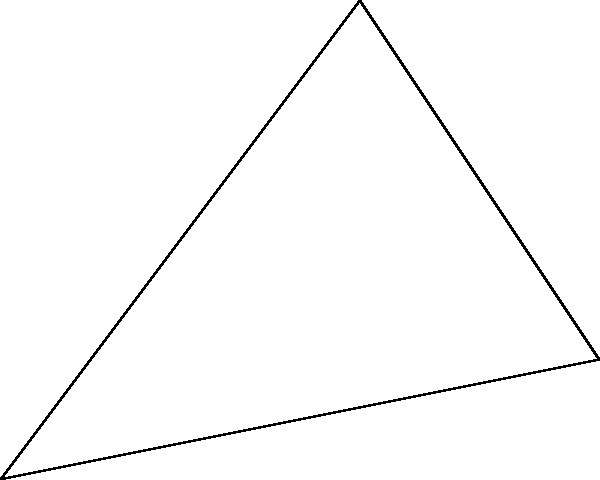In a plant's stem growth pattern, two branches emerge from the main stem at point O. Branch OA makes an angle $\alpha$ with the vertical axis, while branch OB makes an angle $\beta$ with the vertical axis. Given that OA = 5 cm, OB = $\sqrt{26}$ cm, and the horizontal distance between A and B is 2 cm, calculate the branching angle between OA and OB. To find the branching angle between OA and OB, we can follow these steps:

1) First, let's identify the triangle formed by points O, A, and B. We need to find the angle at O in this triangle.

2) We can use the cosine law to find this angle. The cosine law states:
   $c^2 = a^2 + b^2 - 2ab \cos(C)$
   where C is the angle opposite to side c.

3) In our case:
   $OA = 5$ cm
   $OB = \sqrt{26}$ cm
   $AB = 2$ cm (horizontal distance between A and B)

4) Let's call the angle we're looking for $\theta$. Applying the cosine law:
   $AB^2 = OA^2 + OB^2 - 2(OA)(OB)\cos(\theta)$

5) Substituting the known values:
   $2^2 = 5^2 + (\sqrt{26})^2 - 2(5)(\sqrt{26})\cos(\theta)$

6) Simplify:
   $4 = 25 + 26 - 10\sqrt{26}\cos(\theta)$

7) Solve for $\cos(\theta)$:
   $10\sqrt{26}\cos(\theta) = 47$
   $\cos(\theta) = \frac{47}{10\sqrt{26}}$

8) To get $\theta$, we take the inverse cosine (arccos) of both sides:
   $\theta = \arccos(\frac{47}{10\sqrt{26}})$

9) Calculate this value:
   $\theta \approx 0.5305$ radians or $30.4°$

Therefore, the branching angle between OA and OB is approximately 30.4°.
Answer: $\arccos(\frac{47}{10\sqrt{26}}) \approx 30.4°$ 